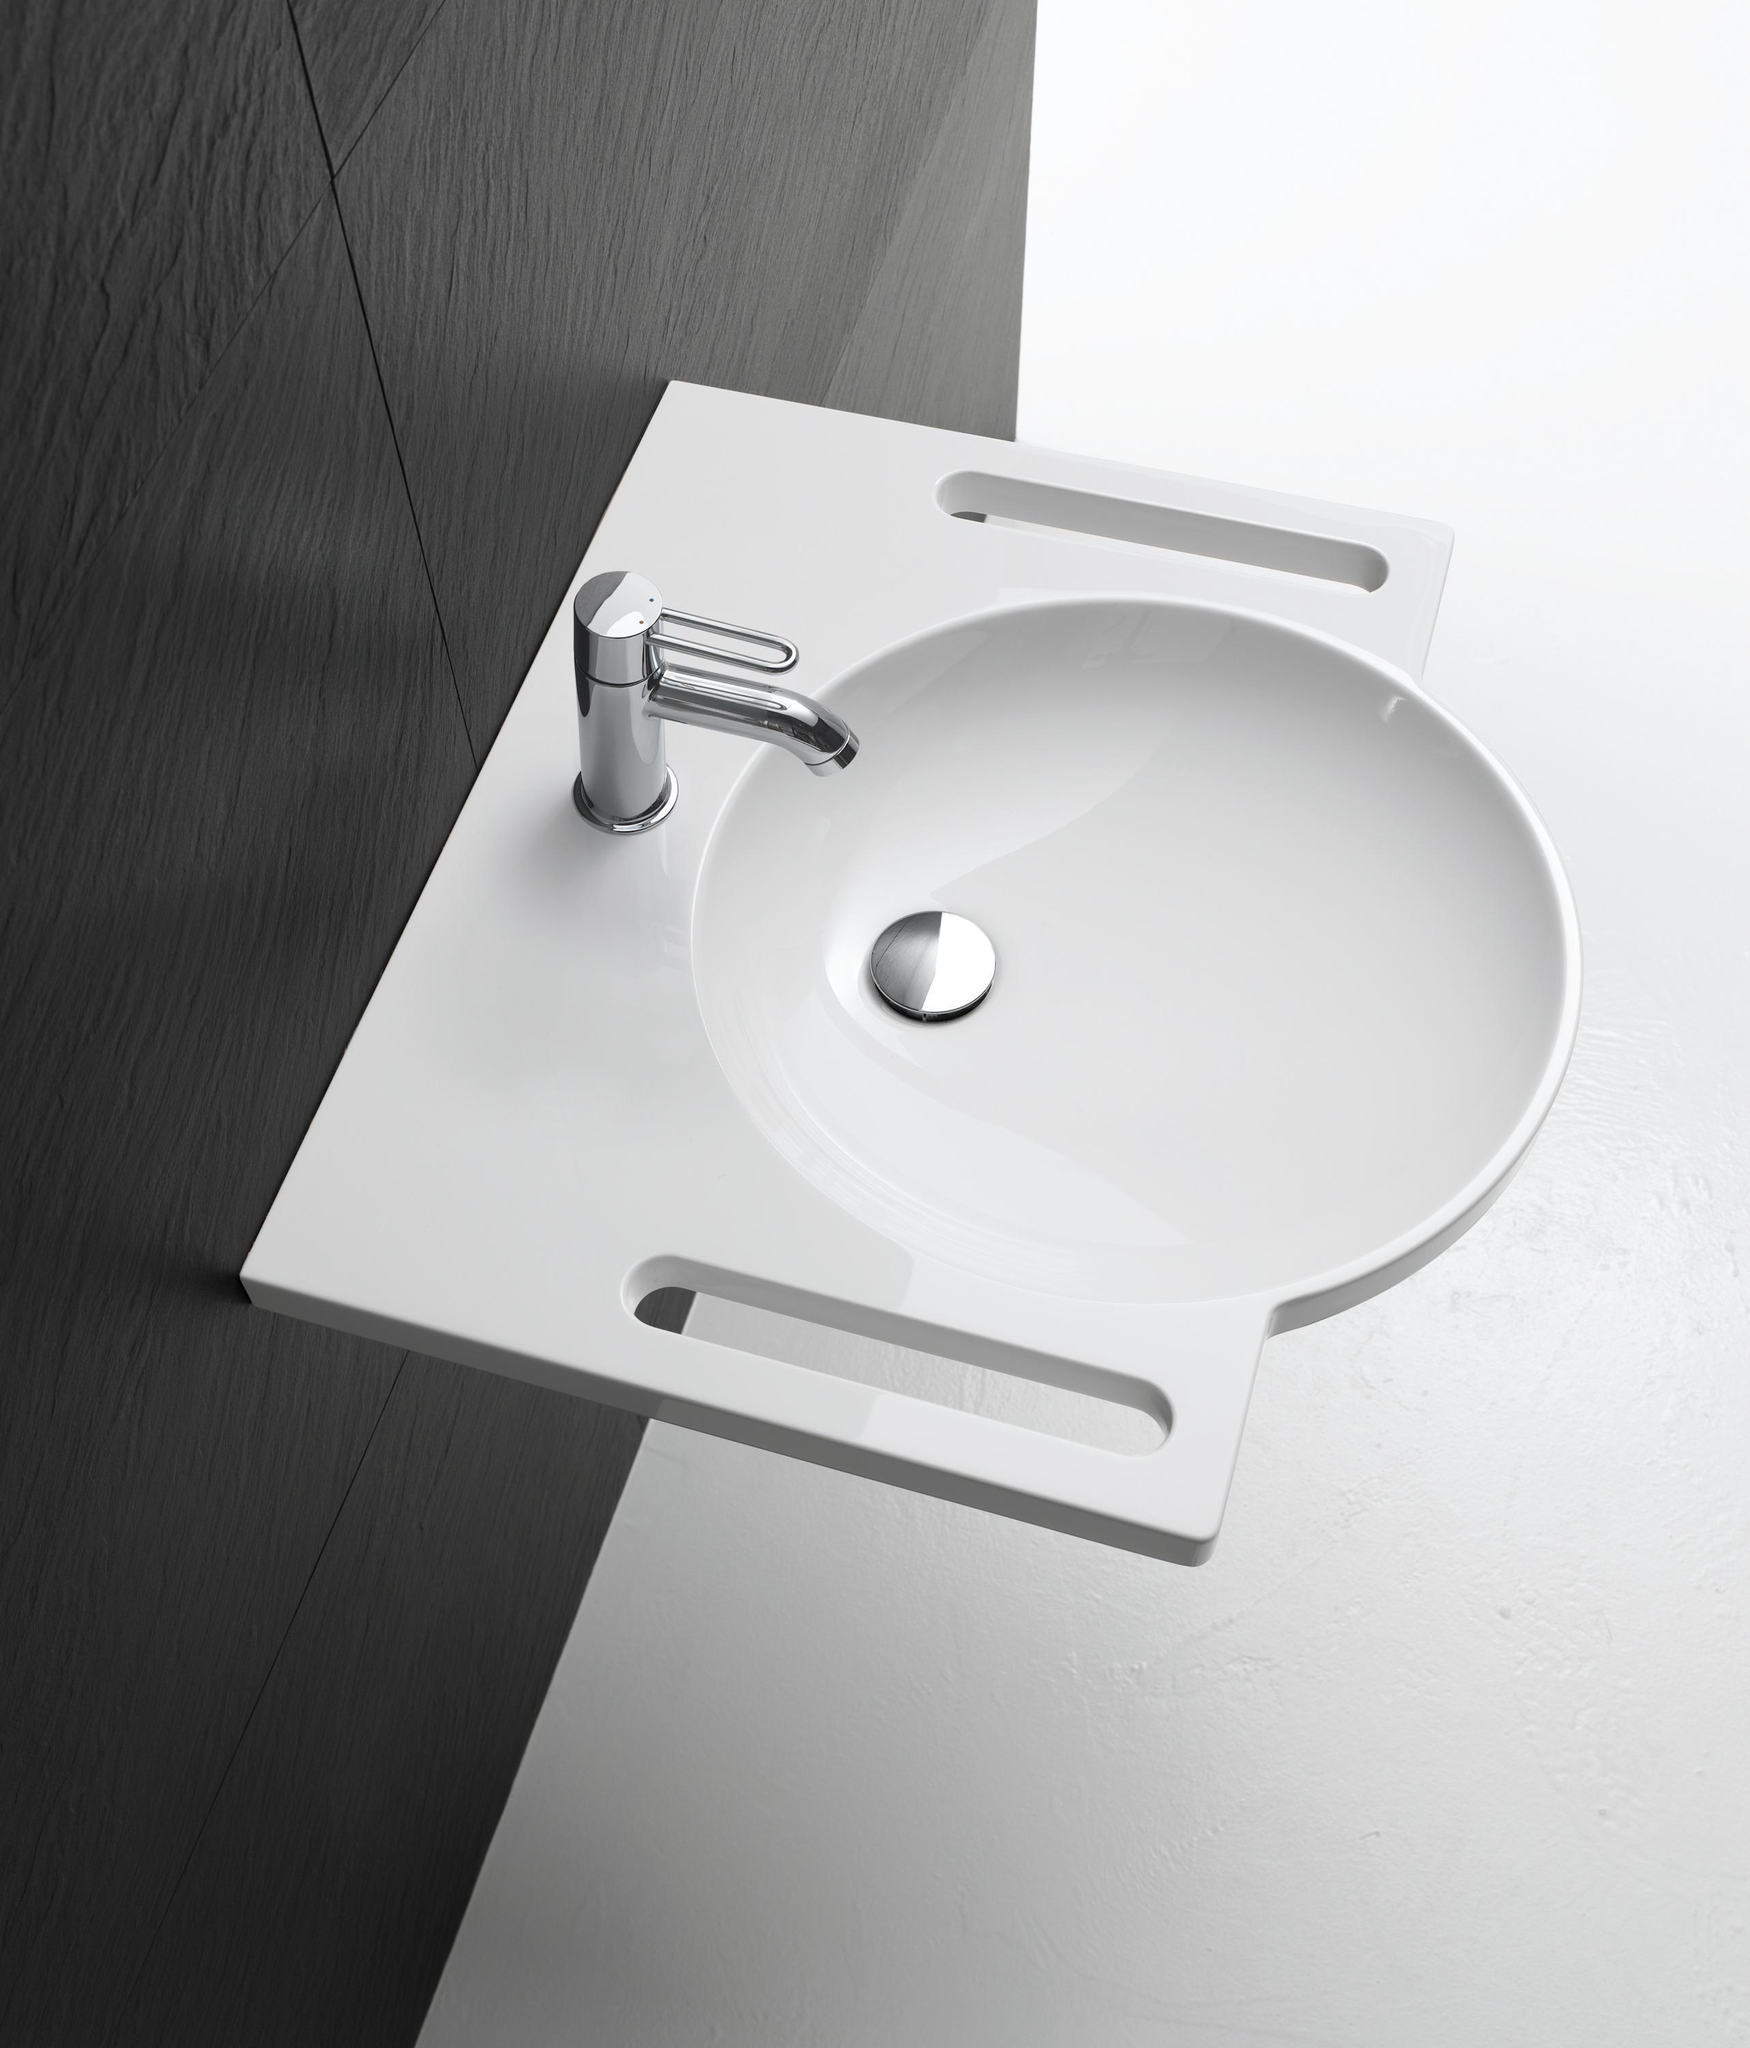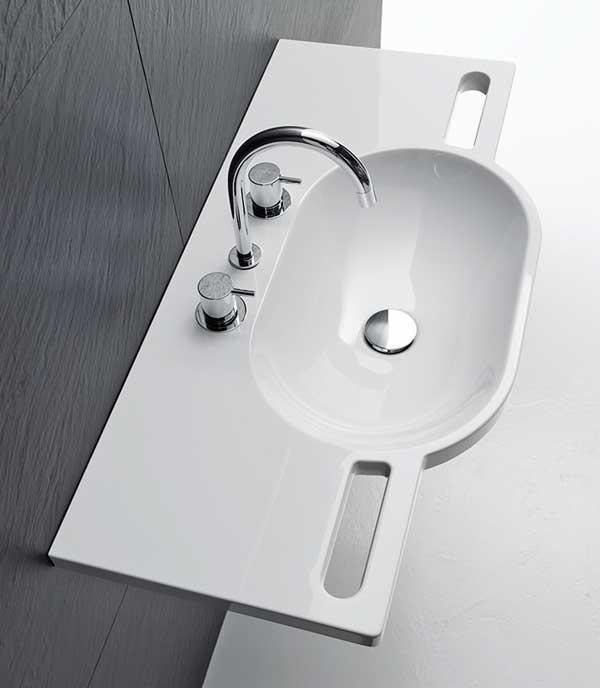The first image is the image on the left, the second image is the image on the right. Considering the images on both sides, is "A rectangular mirror hangs over  a wash basin in one of the images." valid? Answer yes or no. No. 